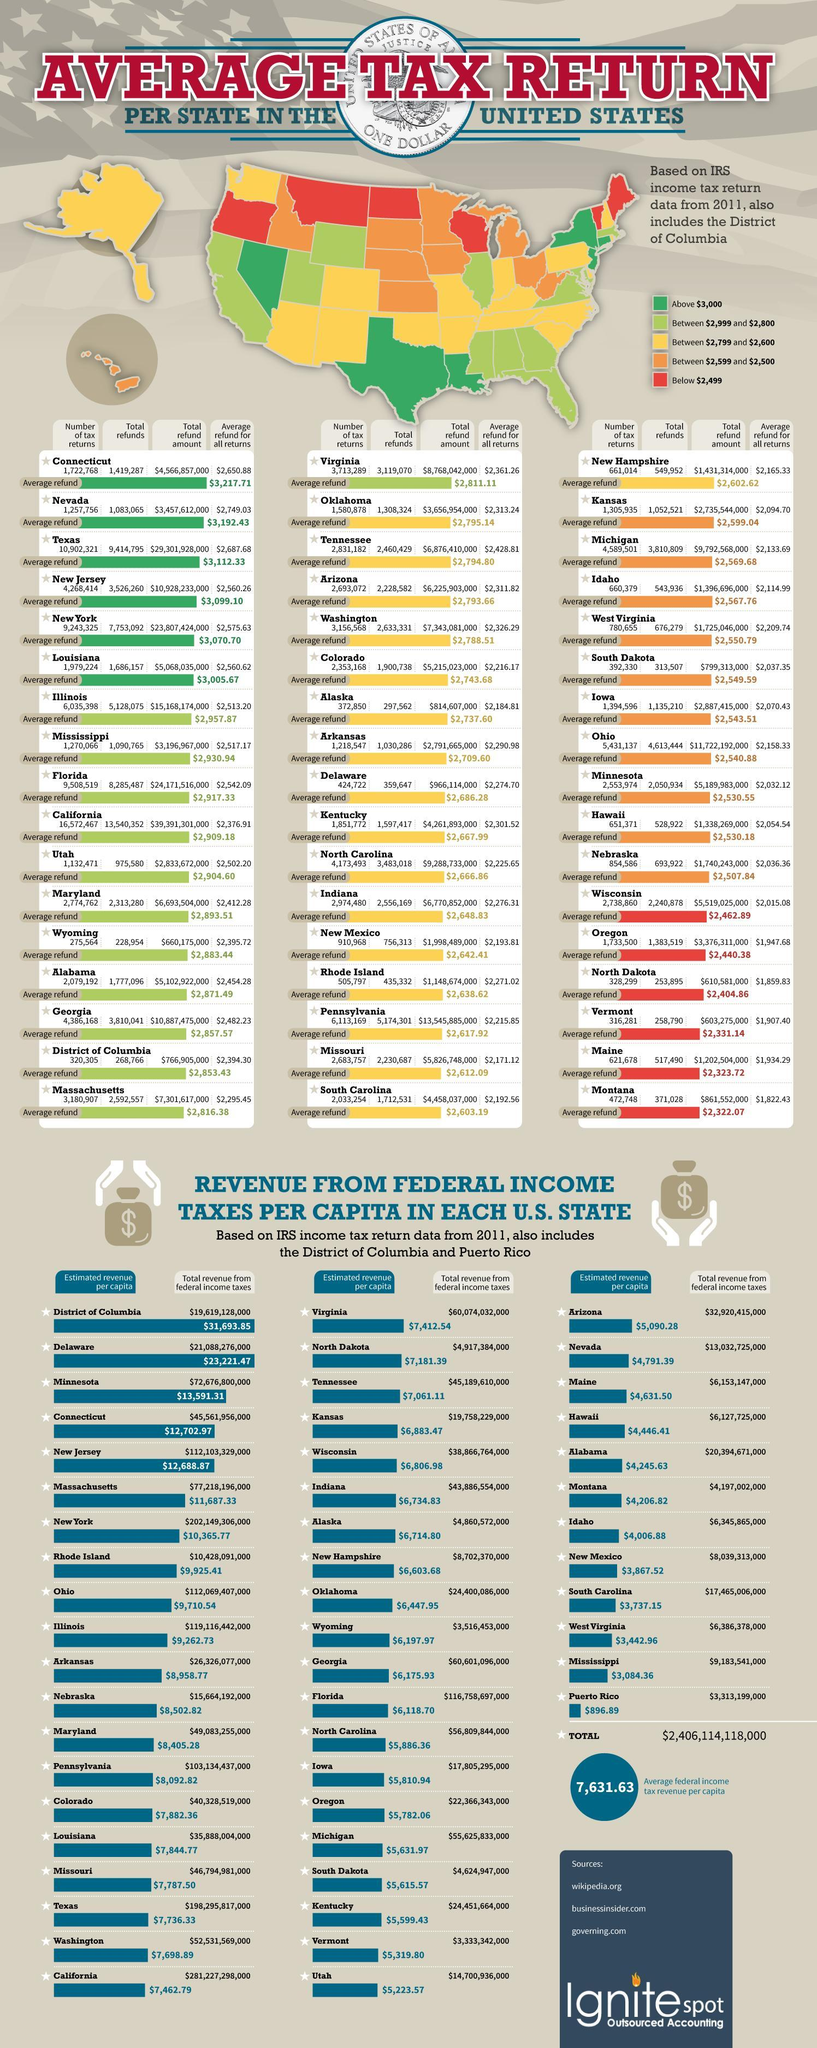what does the legend in yellow show
Answer the question with a short phrase. between $2,799 and $2,600 what is the average refund for all returns for Idaho $2,114.99 how many states are in red 6 what is the total revenue from federal income taxes for north dakota $4,917,384,000 what is the average refund of Oklahoma 2,795.14 what is the total refund for Louisiana 1,686,157 what is the estimated revenue per capita for kansas $6,883.47 